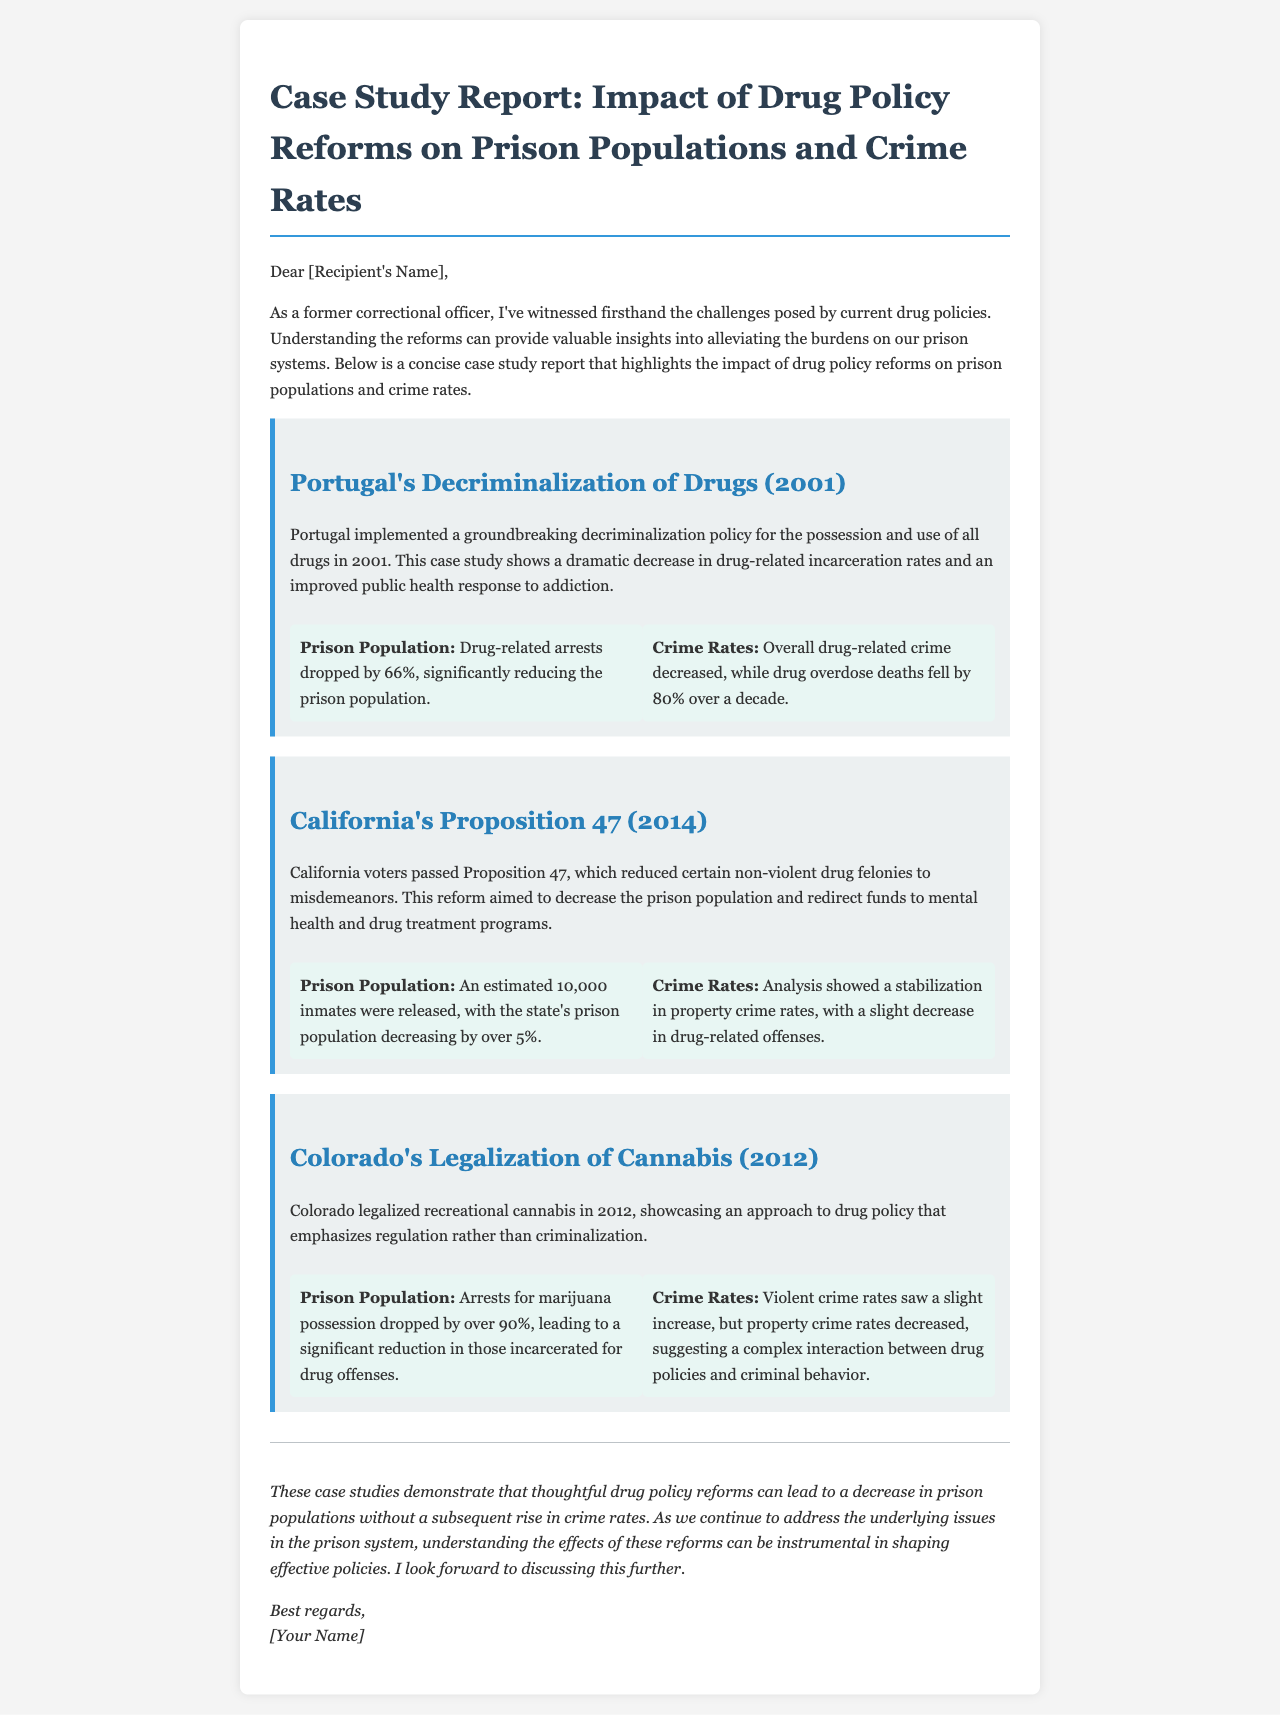What year did Portugal implement drug decriminalization? The document states that Portugal implemented its decriminalization policy in 2001.
Answer: 2001 What percentage did drug-related arrests drop in Portugal? The document mentions that drug-related arrests in Portugal dropped by 66%.
Answer: 66% How many inmates were released due to California's Proposition 47? According to the document, an estimated 10,000 inmates were released due to this reform.
Answer: 10,000 What was the impact on drug overdose deaths in Portugal over a decade? The document indicates that drug overdose deaths in Portugal fell by 80% over a decade.
Answer: 80% What approach does Colorado's legalization of cannabis emphasize? The document describes Colorado's approach as one that emphasizes regulation rather than criminalization.
Answer: Regulation What was the percentage decrease in marijuana possession arrests in Colorado? The document states that arrests for marijuana possession dropped by over 90% in Colorado.
Answer: Over 90% What does the conclusion suggest about drug policy reforms and prison populations? The conclusion indicates that thoughtful drug policy reforms can lead to a decrease in prison populations.
Answer: Decrease What specific type of crimes stabilized in California after Proposition 47? The document notes that property crime rates stabilized after the implementation of Proposition 47.
Answer: Property crime rates Who authored the email containing the case study report? The document states that the email is authored by "[Your Name]."
Answer: [Your Name] 